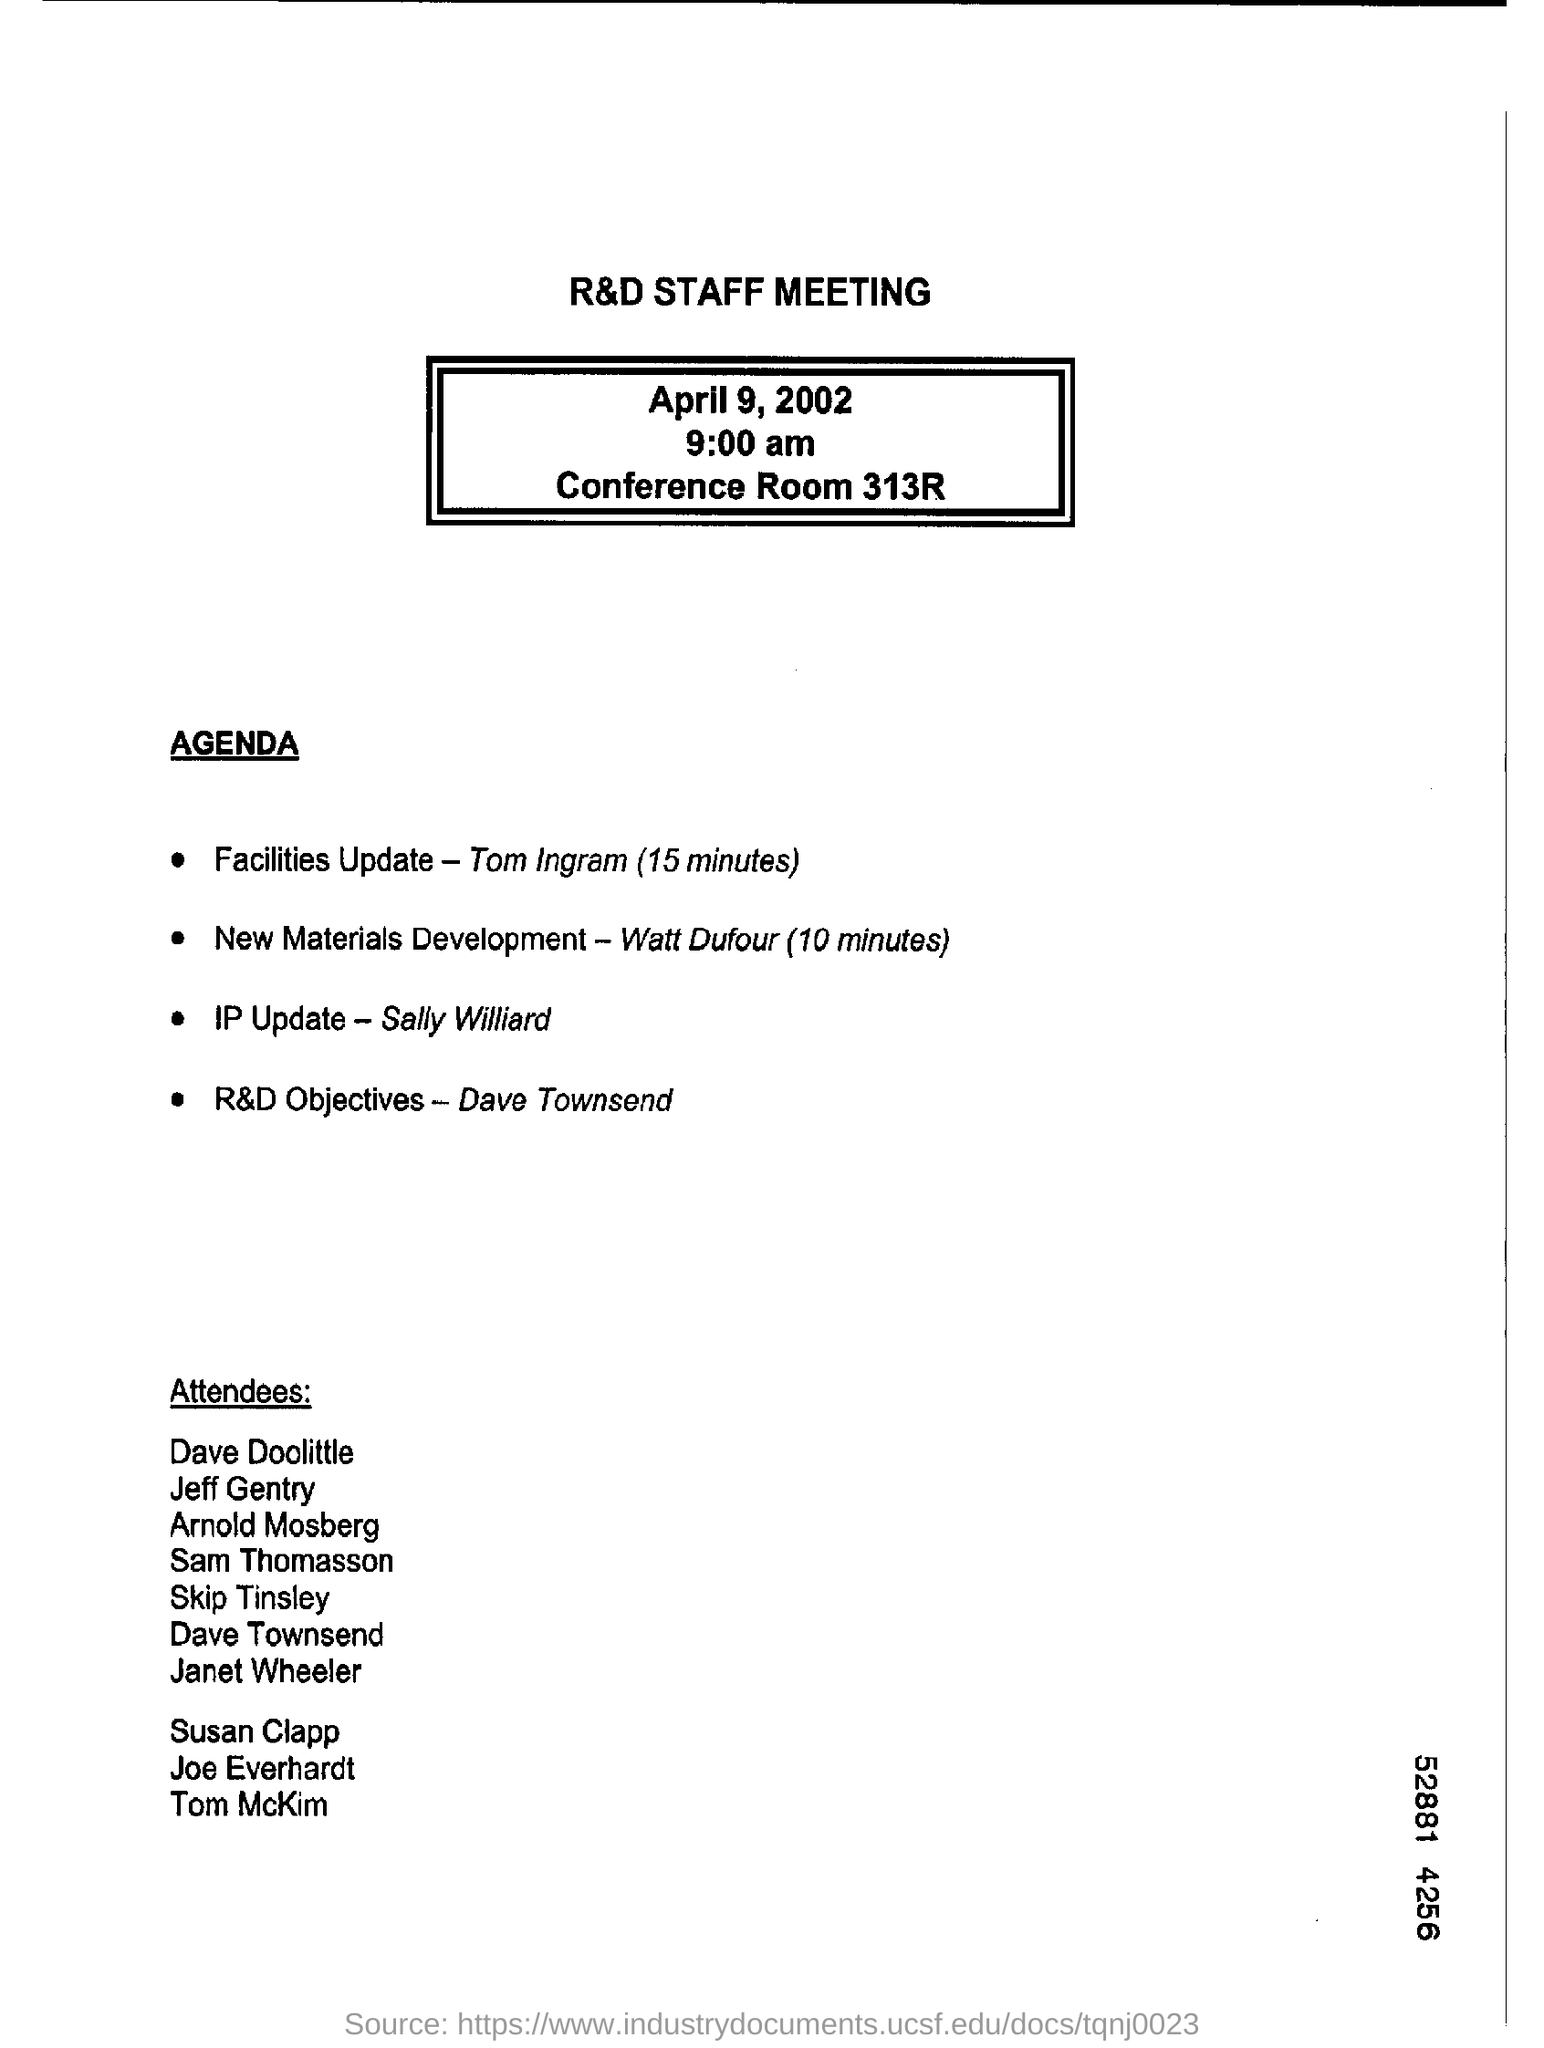Indicate a few pertinent items in this graphic. The R&D Staff Meeting will be held on April 9, 2002. Sally Williard will head the update of intellectual property. Dave Townsend's topic of interest is the achievement of Research and Development objectives. The meeting is scheduled to begin at 9:00 am. The meeting will be held at Conference Room 313R, and the venue is unknown. 